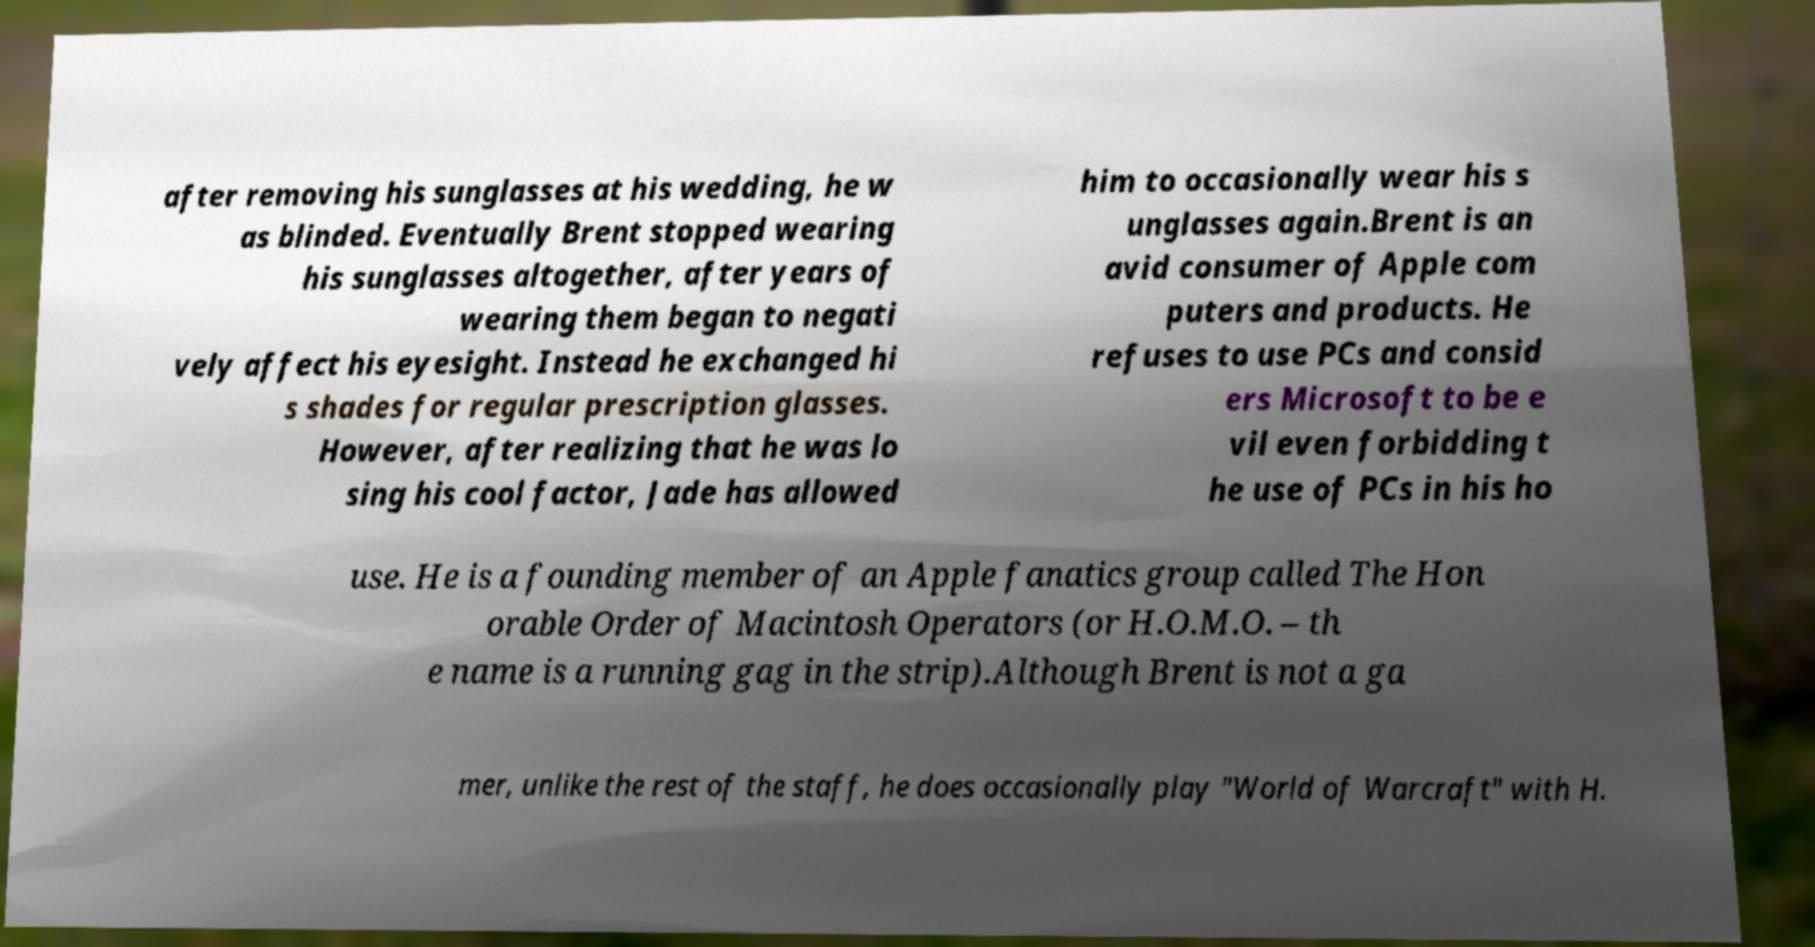Please identify and transcribe the text found in this image. after removing his sunglasses at his wedding, he w as blinded. Eventually Brent stopped wearing his sunglasses altogether, after years of wearing them began to negati vely affect his eyesight. Instead he exchanged hi s shades for regular prescription glasses. However, after realizing that he was lo sing his cool factor, Jade has allowed him to occasionally wear his s unglasses again.Brent is an avid consumer of Apple com puters and products. He refuses to use PCs and consid ers Microsoft to be e vil even forbidding t he use of PCs in his ho use. He is a founding member of an Apple fanatics group called The Hon orable Order of Macintosh Operators (or H.O.M.O. – th e name is a running gag in the strip).Although Brent is not a ga mer, unlike the rest of the staff, he does occasionally play "World of Warcraft" with H. 